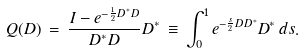Convert formula to latex. <formula><loc_0><loc_0><loc_500><loc_500>Q ( D ) \, = \, \frac { I - e ^ { - \frac { 1 } { 2 } D ^ { * } D } } { D ^ { * } D } D ^ { * } \, \equiv \, \int _ { 0 } ^ { 1 } e ^ { - \frac { s } { 2 } D D ^ { * } } D ^ { * } \, d s .</formula> 